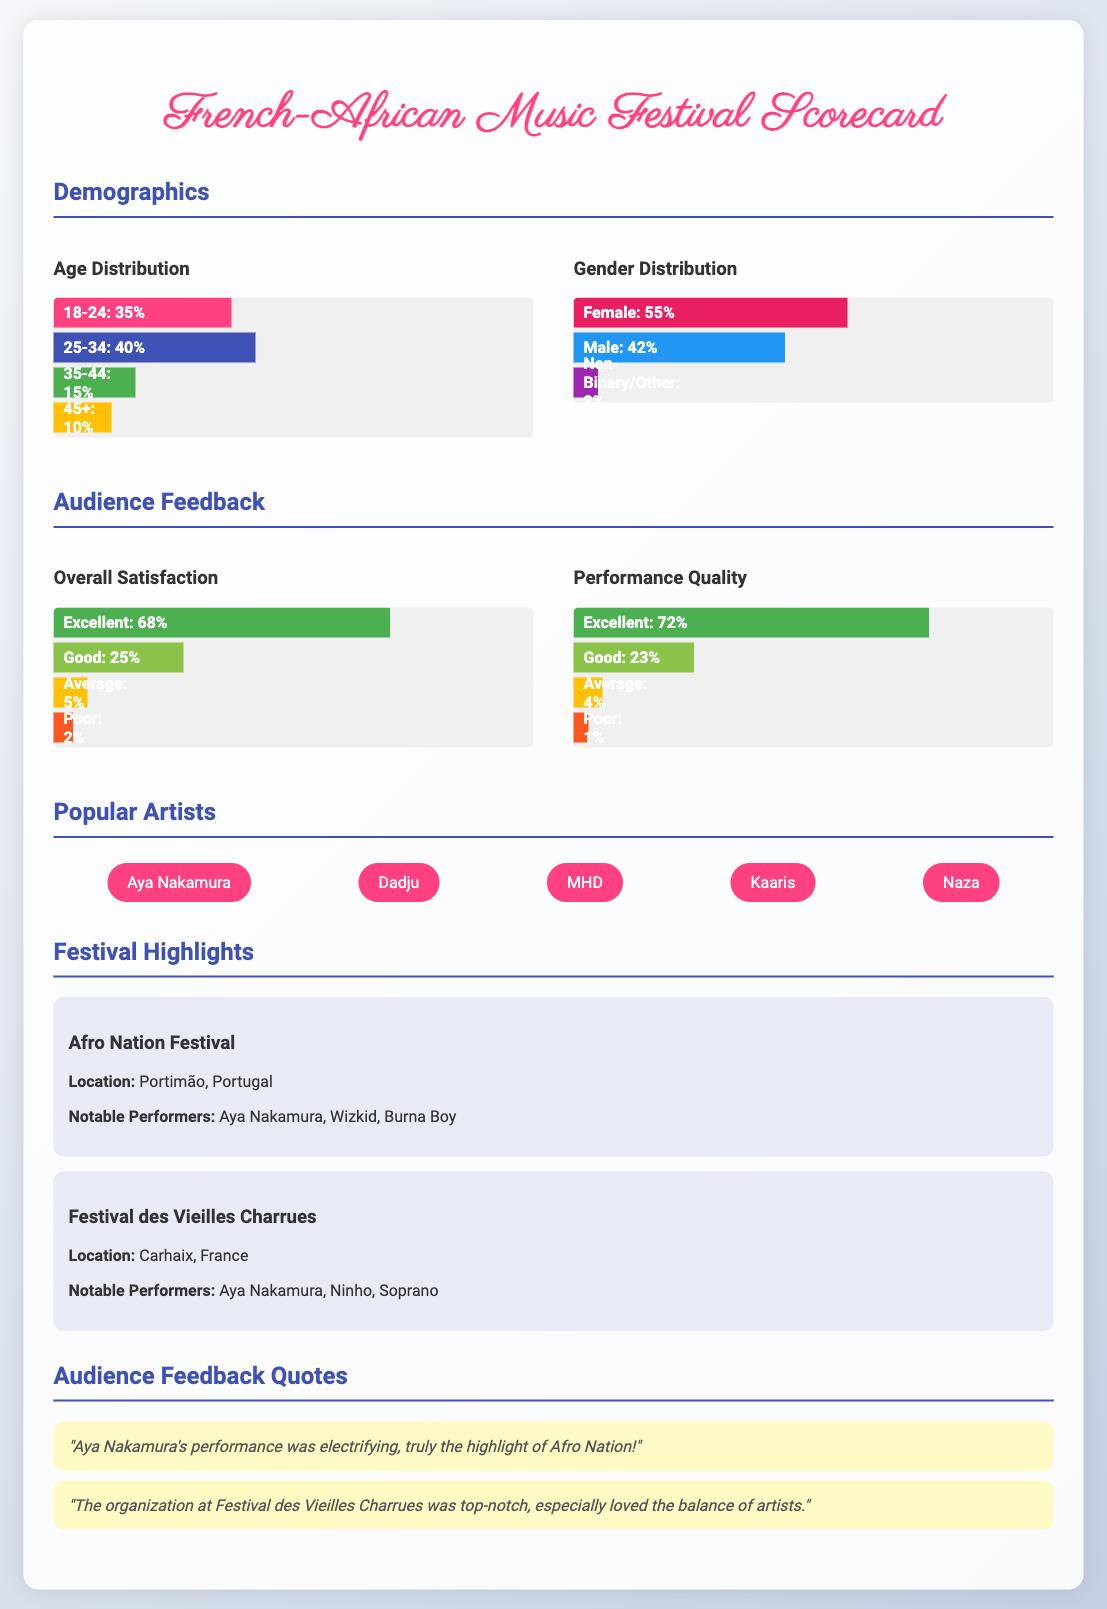What is the age group with the highest percentage? The age group with the highest percentage is 25-34, which accounts for 40%.
Answer: 25-34 What percentage of the audience identified as Female? The document states that 55% of the audience identified as Female.
Answer: 55% What is the overall satisfaction percentage that rated as Excellent? 68% of the audience rated their overall satisfaction as Excellent.
Answer: 68% Which artist has the highest popularity mentioned? The most popular artist mentioned in the document is Aya Nakamura.
Answer: Aya Nakamura In which location is the Afro Nation Festival held? The Afro Nation Festival is held in Portimão, Portugal.
Answer: Portimão, Portugal What percentage of the audience found the performance quality to be Poor? Only 1% of the audience rated the performance quality as Poor.
Answer: 1% Which festival featured Aya Nakamura and Ninho? The Festival des Vieilles Charrues featured Aya Nakamura and Ninho.
Answer: Festival des Vieilles Charrues What is the total percentage of the audience that rated the overall satisfaction as Average or Poor? The total percentage for Average (5%) and Poor (2%) is 7%.
Answer: 7% What is the primary theme of the quotes from audience feedback? The primary theme of the quotes revolves around the quality of performances and organization.
Answer: Quality of performances and organization 